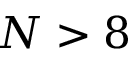<formula> <loc_0><loc_0><loc_500><loc_500>N > 8</formula> 